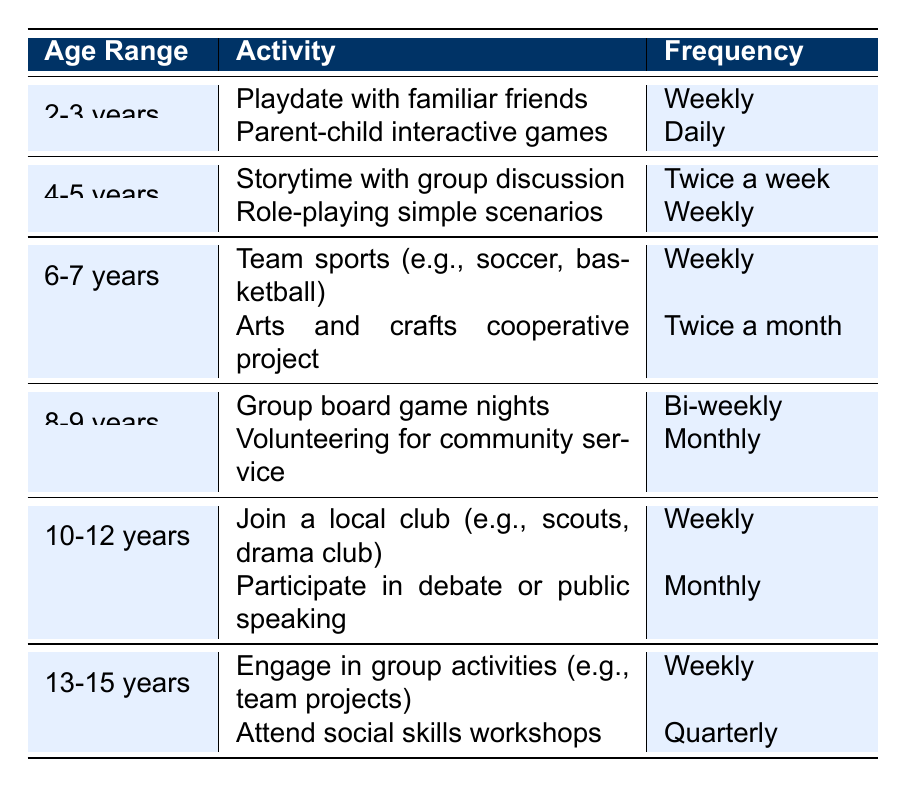What activities are suggested for children aged 4-5 years? Referring to the table, for the age range of 4-5 years, the activities listed are "Storytime with group discussion" and "Role-playing simple scenarios."
Answer: Storytime with group discussion, Role-playing simple scenarios How often should children aged 10-12 years join a local club? The table indicates that children in this age range should join a local club weekly.
Answer: Weekly Are there any activities for children aged 2-3 years that occur daily? By checking the table, "Parent-child interactive games" is the only activity for this age range that is conducted daily.
Answer: Yes What is the frequency of volunteering for community service for children aged 8-9 years? The table states that the frequency of volunteering for community service for this age group is monthly.
Answer: Monthly How many activities are there for children aged 6-7 years? The table shows two activities listed for the age range of 6-7 years: "Team sports (e.g., soccer, basketball)" and "Arts and crafts cooperative project."
Answer: Two activities If a parent wants their child in the 2-3 year age range to engage in social skills activities twice a week, are there any suitable options? The table lists no activities for 2-3 years that occur at that frequency; the options available are either daily or weekly.
Answer: No Which age group has the most activities listed in the table? By counting the activities from each age range, there are two activities listed for each age group up to 13-15 years. All age groups have the same number of activities, except 13-15, which has two.
Answer: All groups have two activities except 13-15 years Are there any activities that involve teamwork for children under 6 years old? The table indicates that both activities for the ages of 2-3 years and 4-5 years are more individual or parent-focused rather than explicitly involving teamwork.
Answer: No What is the frequency difference between arts and crafts cooperative projects and group board game nights? Arts and crafts cooperative projects are twice a month, while group board game nights are bi-weekly (every two weeks), which equates to about twice a month. The difference in frequency is negligible.
Answer: None; they are equivalent Which activities occur quarterly, and for which age range? From the table, the only activity listed as occurring quarterly is "Attend social skills workshops," which is for children in the age range of 13-15 years.
Answer: Attend social skills workshops for 13-15 years 